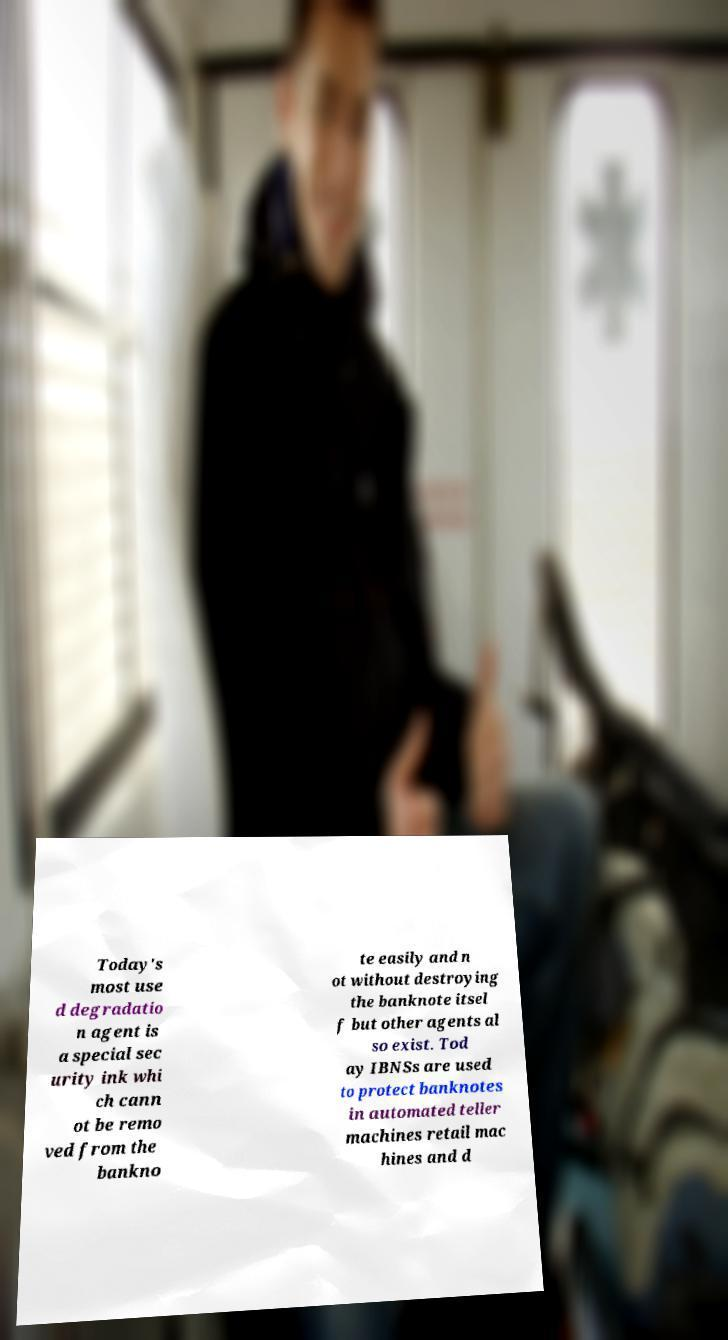Please identify and transcribe the text found in this image. Today's most use d degradatio n agent is a special sec urity ink whi ch cann ot be remo ved from the bankno te easily and n ot without destroying the banknote itsel f but other agents al so exist. Tod ay IBNSs are used to protect banknotes in automated teller machines retail mac hines and d 